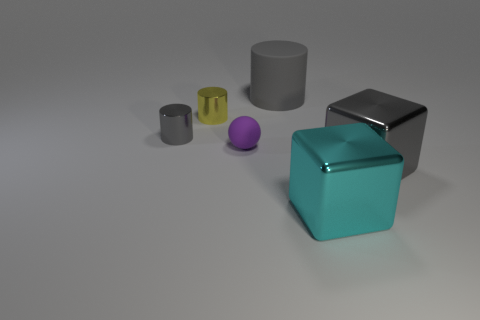Add 2 tiny purple matte spheres. How many objects exist? 8 Subtract all cubes. How many objects are left? 4 Subtract 0 green balls. How many objects are left? 6 Subtract all red objects. Subtract all big matte cylinders. How many objects are left? 5 Add 1 big rubber cylinders. How many big rubber cylinders are left? 2 Add 4 purple objects. How many purple objects exist? 5 